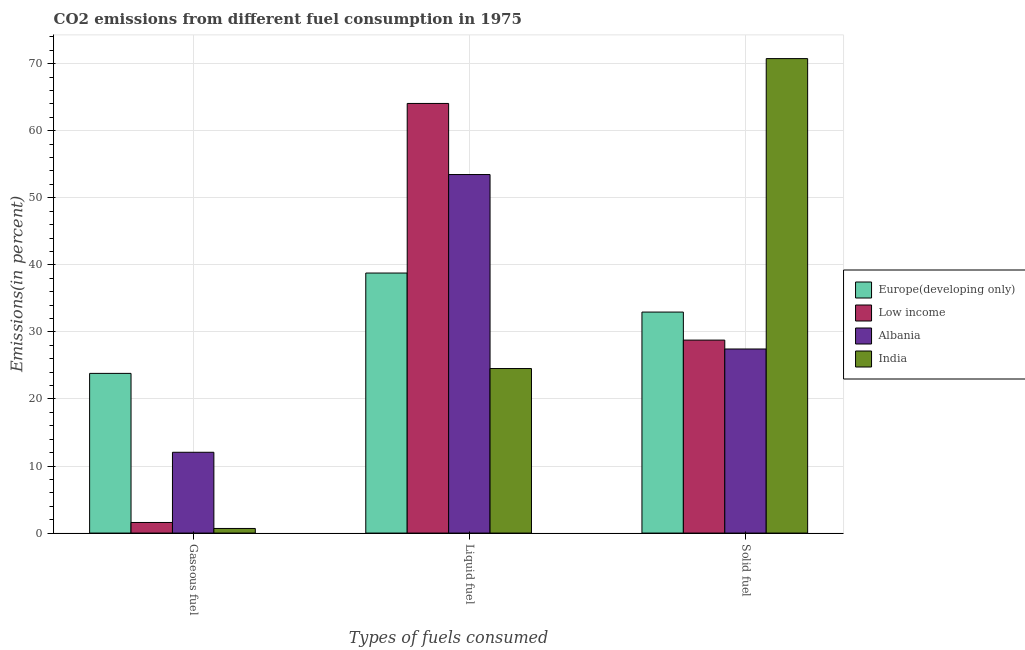Are the number of bars on each tick of the X-axis equal?
Your answer should be very brief. Yes. How many bars are there on the 1st tick from the right?
Offer a terse response. 4. What is the label of the 3rd group of bars from the left?
Your answer should be compact. Solid fuel. What is the percentage of solid fuel emission in Albania?
Provide a succinct answer. 27.45. Across all countries, what is the maximum percentage of liquid fuel emission?
Give a very brief answer. 64.07. Across all countries, what is the minimum percentage of solid fuel emission?
Give a very brief answer. 27.45. In which country was the percentage of gaseous fuel emission maximum?
Keep it short and to the point. Europe(developing only). In which country was the percentage of solid fuel emission minimum?
Make the answer very short. Albania. What is the total percentage of gaseous fuel emission in the graph?
Your answer should be compact. 38.14. What is the difference between the percentage of liquid fuel emission in Albania and that in Low income?
Offer a terse response. -10.6. What is the difference between the percentage of gaseous fuel emission in Europe(developing only) and the percentage of solid fuel emission in India?
Offer a terse response. -46.95. What is the average percentage of liquid fuel emission per country?
Keep it short and to the point. 45.22. What is the difference between the percentage of solid fuel emission and percentage of gaseous fuel emission in Albania?
Make the answer very short. 15.4. What is the ratio of the percentage of gaseous fuel emission in India to that in Europe(developing only)?
Ensure brevity in your answer.  0.03. Is the difference between the percentage of liquid fuel emission in Albania and Europe(developing only) greater than the difference between the percentage of gaseous fuel emission in Albania and Europe(developing only)?
Make the answer very short. Yes. What is the difference between the highest and the second highest percentage of liquid fuel emission?
Your answer should be very brief. 10.6. What is the difference between the highest and the lowest percentage of liquid fuel emission?
Your answer should be very brief. 39.53. In how many countries, is the percentage of gaseous fuel emission greater than the average percentage of gaseous fuel emission taken over all countries?
Give a very brief answer. 2. What does the 3rd bar from the left in Liquid fuel represents?
Make the answer very short. Albania. Are all the bars in the graph horizontal?
Provide a short and direct response. No. What is the difference between two consecutive major ticks on the Y-axis?
Offer a very short reply. 10. How many legend labels are there?
Provide a succinct answer. 4. How are the legend labels stacked?
Offer a terse response. Vertical. What is the title of the graph?
Your answer should be very brief. CO2 emissions from different fuel consumption in 1975. What is the label or title of the X-axis?
Give a very brief answer. Types of fuels consumed. What is the label or title of the Y-axis?
Ensure brevity in your answer.  Emissions(in percent). What is the Emissions(in percent) of Europe(developing only) in Gaseous fuel?
Your response must be concise. 23.82. What is the Emissions(in percent) in Low income in Gaseous fuel?
Offer a very short reply. 1.58. What is the Emissions(in percent) of Albania in Gaseous fuel?
Your answer should be compact. 12.05. What is the Emissions(in percent) of India in Gaseous fuel?
Make the answer very short. 0.69. What is the Emissions(in percent) of Europe(developing only) in Liquid fuel?
Your answer should be compact. 38.78. What is the Emissions(in percent) of Low income in Liquid fuel?
Offer a terse response. 64.07. What is the Emissions(in percent) of Albania in Liquid fuel?
Offer a very short reply. 53.47. What is the Emissions(in percent) in India in Liquid fuel?
Make the answer very short. 24.54. What is the Emissions(in percent) of Europe(developing only) in Solid fuel?
Provide a short and direct response. 32.96. What is the Emissions(in percent) of Low income in Solid fuel?
Ensure brevity in your answer.  28.78. What is the Emissions(in percent) of Albania in Solid fuel?
Your response must be concise. 27.45. What is the Emissions(in percent) in India in Solid fuel?
Give a very brief answer. 70.76. Across all Types of fuels consumed, what is the maximum Emissions(in percent) of Europe(developing only)?
Ensure brevity in your answer.  38.78. Across all Types of fuels consumed, what is the maximum Emissions(in percent) in Low income?
Provide a succinct answer. 64.07. Across all Types of fuels consumed, what is the maximum Emissions(in percent) in Albania?
Keep it short and to the point. 53.47. Across all Types of fuels consumed, what is the maximum Emissions(in percent) of India?
Offer a terse response. 70.76. Across all Types of fuels consumed, what is the minimum Emissions(in percent) of Europe(developing only)?
Offer a terse response. 23.82. Across all Types of fuels consumed, what is the minimum Emissions(in percent) of Low income?
Give a very brief answer. 1.58. Across all Types of fuels consumed, what is the minimum Emissions(in percent) of Albania?
Make the answer very short. 12.05. Across all Types of fuels consumed, what is the minimum Emissions(in percent) of India?
Offer a terse response. 0.69. What is the total Emissions(in percent) of Europe(developing only) in the graph?
Your answer should be compact. 95.56. What is the total Emissions(in percent) in Low income in the graph?
Your answer should be very brief. 94.43. What is the total Emissions(in percent) of Albania in the graph?
Give a very brief answer. 92.98. What is the total Emissions(in percent) in India in the graph?
Offer a very short reply. 95.99. What is the difference between the Emissions(in percent) of Europe(developing only) in Gaseous fuel and that in Liquid fuel?
Your response must be concise. -14.96. What is the difference between the Emissions(in percent) in Low income in Gaseous fuel and that in Liquid fuel?
Offer a terse response. -62.49. What is the difference between the Emissions(in percent) in Albania in Gaseous fuel and that in Liquid fuel?
Give a very brief answer. -41.42. What is the difference between the Emissions(in percent) in India in Gaseous fuel and that in Liquid fuel?
Make the answer very short. -23.85. What is the difference between the Emissions(in percent) in Europe(developing only) in Gaseous fuel and that in Solid fuel?
Provide a short and direct response. -9.14. What is the difference between the Emissions(in percent) of Low income in Gaseous fuel and that in Solid fuel?
Offer a very short reply. -27.2. What is the difference between the Emissions(in percent) of Albania in Gaseous fuel and that in Solid fuel?
Ensure brevity in your answer.  -15.4. What is the difference between the Emissions(in percent) of India in Gaseous fuel and that in Solid fuel?
Your response must be concise. -70.08. What is the difference between the Emissions(in percent) of Europe(developing only) in Liquid fuel and that in Solid fuel?
Ensure brevity in your answer.  5.82. What is the difference between the Emissions(in percent) in Low income in Liquid fuel and that in Solid fuel?
Your answer should be very brief. 35.29. What is the difference between the Emissions(in percent) in Albania in Liquid fuel and that in Solid fuel?
Give a very brief answer. 26.02. What is the difference between the Emissions(in percent) of India in Liquid fuel and that in Solid fuel?
Give a very brief answer. -46.22. What is the difference between the Emissions(in percent) in Europe(developing only) in Gaseous fuel and the Emissions(in percent) in Low income in Liquid fuel?
Provide a short and direct response. -40.26. What is the difference between the Emissions(in percent) in Europe(developing only) in Gaseous fuel and the Emissions(in percent) in Albania in Liquid fuel?
Give a very brief answer. -29.66. What is the difference between the Emissions(in percent) in Europe(developing only) in Gaseous fuel and the Emissions(in percent) in India in Liquid fuel?
Give a very brief answer. -0.72. What is the difference between the Emissions(in percent) in Low income in Gaseous fuel and the Emissions(in percent) in Albania in Liquid fuel?
Provide a succinct answer. -51.89. What is the difference between the Emissions(in percent) of Low income in Gaseous fuel and the Emissions(in percent) of India in Liquid fuel?
Provide a succinct answer. -22.96. What is the difference between the Emissions(in percent) in Albania in Gaseous fuel and the Emissions(in percent) in India in Liquid fuel?
Your answer should be very brief. -12.49. What is the difference between the Emissions(in percent) of Europe(developing only) in Gaseous fuel and the Emissions(in percent) of Low income in Solid fuel?
Provide a short and direct response. -4.96. What is the difference between the Emissions(in percent) of Europe(developing only) in Gaseous fuel and the Emissions(in percent) of Albania in Solid fuel?
Your answer should be very brief. -3.64. What is the difference between the Emissions(in percent) in Europe(developing only) in Gaseous fuel and the Emissions(in percent) in India in Solid fuel?
Keep it short and to the point. -46.95. What is the difference between the Emissions(in percent) of Low income in Gaseous fuel and the Emissions(in percent) of Albania in Solid fuel?
Offer a very short reply. -25.87. What is the difference between the Emissions(in percent) of Low income in Gaseous fuel and the Emissions(in percent) of India in Solid fuel?
Offer a terse response. -69.18. What is the difference between the Emissions(in percent) of Albania in Gaseous fuel and the Emissions(in percent) of India in Solid fuel?
Keep it short and to the point. -58.71. What is the difference between the Emissions(in percent) in Europe(developing only) in Liquid fuel and the Emissions(in percent) in Low income in Solid fuel?
Offer a very short reply. 10. What is the difference between the Emissions(in percent) of Europe(developing only) in Liquid fuel and the Emissions(in percent) of Albania in Solid fuel?
Your response must be concise. 11.33. What is the difference between the Emissions(in percent) in Europe(developing only) in Liquid fuel and the Emissions(in percent) in India in Solid fuel?
Offer a terse response. -31.98. What is the difference between the Emissions(in percent) of Low income in Liquid fuel and the Emissions(in percent) of Albania in Solid fuel?
Keep it short and to the point. 36.62. What is the difference between the Emissions(in percent) in Low income in Liquid fuel and the Emissions(in percent) in India in Solid fuel?
Give a very brief answer. -6.69. What is the difference between the Emissions(in percent) of Albania in Liquid fuel and the Emissions(in percent) of India in Solid fuel?
Ensure brevity in your answer.  -17.29. What is the average Emissions(in percent) of Europe(developing only) per Types of fuels consumed?
Offer a very short reply. 31.85. What is the average Emissions(in percent) of Low income per Types of fuels consumed?
Give a very brief answer. 31.48. What is the average Emissions(in percent) in Albania per Types of fuels consumed?
Your response must be concise. 30.99. What is the average Emissions(in percent) in India per Types of fuels consumed?
Offer a very short reply. 32. What is the difference between the Emissions(in percent) of Europe(developing only) and Emissions(in percent) of Low income in Gaseous fuel?
Offer a very short reply. 22.24. What is the difference between the Emissions(in percent) in Europe(developing only) and Emissions(in percent) in Albania in Gaseous fuel?
Make the answer very short. 11.77. What is the difference between the Emissions(in percent) in Europe(developing only) and Emissions(in percent) in India in Gaseous fuel?
Ensure brevity in your answer.  23.13. What is the difference between the Emissions(in percent) of Low income and Emissions(in percent) of Albania in Gaseous fuel?
Your answer should be compact. -10.47. What is the difference between the Emissions(in percent) of Low income and Emissions(in percent) of India in Gaseous fuel?
Your answer should be compact. 0.89. What is the difference between the Emissions(in percent) of Albania and Emissions(in percent) of India in Gaseous fuel?
Ensure brevity in your answer.  11.36. What is the difference between the Emissions(in percent) in Europe(developing only) and Emissions(in percent) in Low income in Liquid fuel?
Provide a succinct answer. -25.29. What is the difference between the Emissions(in percent) in Europe(developing only) and Emissions(in percent) in Albania in Liquid fuel?
Ensure brevity in your answer.  -14.69. What is the difference between the Emissions(in percent) in Europe(developing only) and Emissions(in percent) in India in Liquid fuel?
Provide a succinct answer. 14.24. What is the difference between the Emissions(in percent) in Low income and Emissions(in percent) in Albania in Liquid fuel?
Ensure brevity in your answer.  10.6. What is the difference between the Emissions(in percent) of Low income and Emissions(in percent) of India in Liquid fuel?
Ensure brevity in your answer.  39.53. What is the difference between the Emissions(in percent) of Albania and Emissions(in percent) of India in Liquid fuel?
Keep it short and to the point. 28.93. What is the difference between the Emissions(in percent) in Europe(developing only) and Emissions(in percent) in Low income in Solid fuel?
Your answer should be compact. 4.18. What is the difference between the Emissions(in percent) in Europe(developing only) and Emissions(in percent) in Albania in Solid fuel?
Ensure brevity in your answer.  5.51. What is the difference between the Emissions(in percent) of Europe(developing only) and Emissions(in percent) of India in Solid fuel?
Keep it short and to the point. -37.8. What is the difference between the Emissions(in percent) in Low income and Emissions(in percent) in Albania in Solid fuel?
Give a very brief answer. 1.33. What is the difference between the Emissions(in percent) of Low income and Emissions(in percent) of India in Solid fuel?
Offer a very short reply. -41.98. What is the difference between the Emissions(in percent) of Albania and Emissions(in percent) of India in Solid fuel?
Offer a very short reply. -43.31. What is the ratio of the Emissions(in percent) of Europe(developing only) in Gaseous fuel to that in Liquid fuel?
Offer a very short reply. 0.61. What is the ratio of the Emissions(in percent) in Low income in Gaseous fuel to that in Liquid fuel?
Ensure brevity in your answer.  0.02. What is the ratio of the Emissions(in percent) in Albania in Gaseous fuel to that in Liquid fuel?
Offer a terse response. 0.23. What is the ratio of the Emissions(in percent) in India in Gaseous fuel to that in Liquid fuel?
Your response must be concise. 0.03. What is the ratio of the Emissions(in percent) of Europe(developing only) in Gaseous fuel to that in Solid fuel?
Ensure brevity in your answer.  0.72. What is the ratio of the Emissions(in percent) in Low income in Gaseous fuel to that in Solid fuel?
Your answer should be compact. 0.05. What is the ratio of the Emissions(in percent) of Albania in Gaseous fuel to that in Solid fuel?
Ensure brevity in your answer.  0.44. What is the ratio of the Emissions(in percent) of India in Gaseous fuel to that in Solid fuel?
Make the answer very short. 0.01. What is the ratio of the Emissions(in percent) of Europe(developing only) in Liquid fuel to that in Solid fuel?
Keep it short and to the point. 1.18. What is the ratio of the Emissions(in percent) of Low income in Liquid fuel to that in Solid fuel?
Offer a very short reply. 2.23. What is the ratio of the Emissions(in percent) in Albania in Liquid fuel to that in Solid fuel?
Make the answer very short. 1.95. What is the ratio of the Emissions(in percent) in India in Liquid fuel to that in Solid fuel?
Keep it short and to the point. 0.35. What is the difference between the highest and the second highest Emissions(in percent) in Europe(developing only)?
Provide a succinct answer. 5.82. What is the difference between the highest and the second highest Emissions(in percent) in Low income?
Provide a succinct answer. 35.29. What is the difference between the highest and the second highest Emissions(in percent) in Albania?
Ensure brevity in your answer.  26.02. What is the difference between the highest and the second highest Emissions(in percent) in India?
Ensure brevity in your answer.  46.22. What is the difference between the highest and the lowest Emissions(in percent) of Europe(developing only)?
Ensure brevity in your answer.  14.96. What is the difference between the highest and the lowest Emissions(in percent) of Low income?
Give a very brief answer. 62.49. What is the difference between the highest and the lowest Emissions(in percent) of Albania?
Keep it short and to the point. 41.42. What is the difference between the highest and the lowest Emissions(in percent) of India?
Keep it short and to the point. 70.08. 